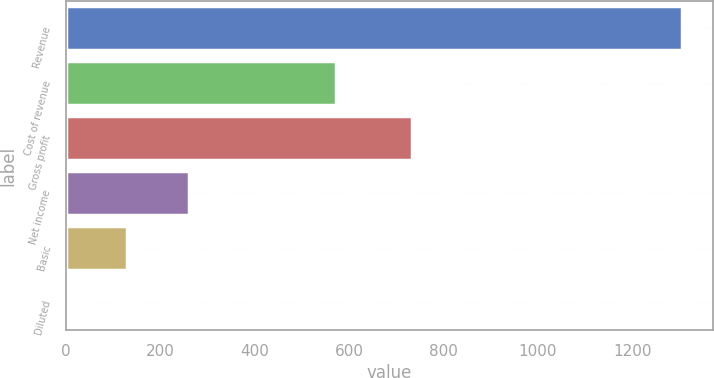Convert chart. <chart><loc_0><loc_0><loc_500><loc_500><bar_chart><fcel>Revenue<fcel>Cost of revenue<fcel>Gross profit<fcel>Net income<fcel>Basic<fcel>Diluted<nl><fcel>1305<fcel>572<fcel>733<fcel>261.36<fcel>130.9<fcel>0.44<nl></chart> 